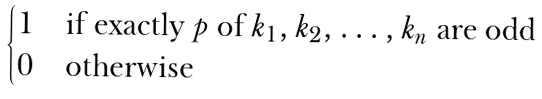<formula> <loc_0><loc_0><loc_500><loc_500>\begin{cases} 1 & \text {if exactly $p$ of $k_{1},k_{2},\dots,k_{n}$ are odd} \\ 0 & \text {otherwise} \end{cases}</formula> 